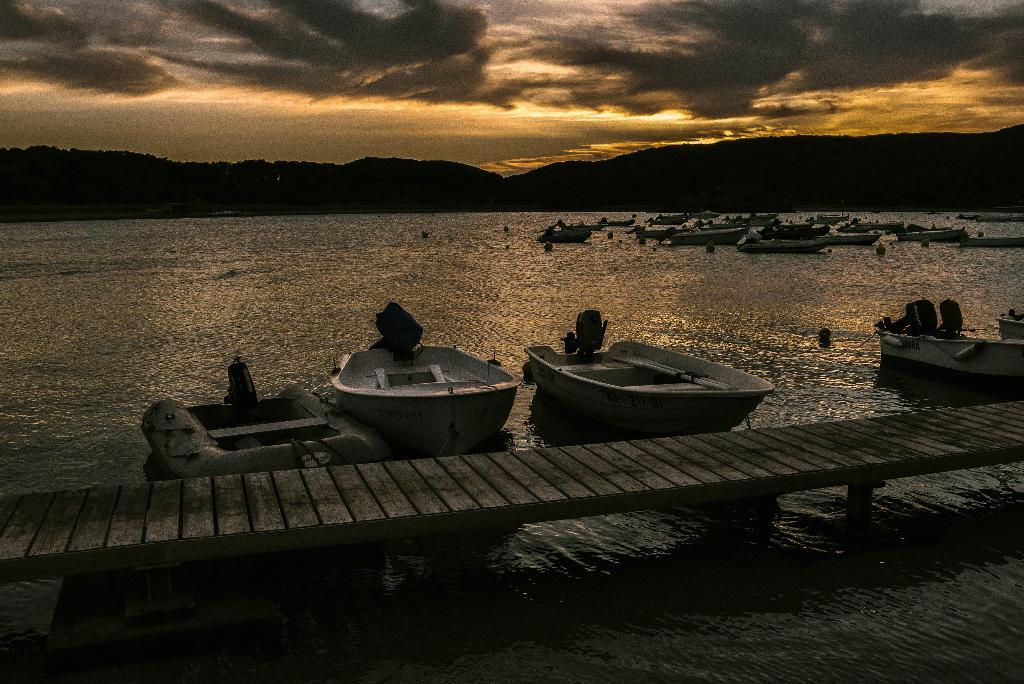What type of vehicles can be seen in the image? There are boats in the image. What structure is present in the image? There is a wooden bridge in the image. What natural element is visible in the image? There is water visible in the image. What is visible at the top of the image? The sky is visible at the top of the image. Reasoning: Let's let's think step by step in order to produce the conversation. We start by identifying the main subjects and objects in the image based on the provided facts. We then formulate questions that focus on the location and characteristics of these subjects and objects, ensuring that each question can be answered definitively with the information given. We avoid yes/no questions and ensure that the language is simple and clear. Absurd Question/Answer: What type of farm animals can be seen grazing on the hour in the image? There is no farm or hour present in the image; it features boats, a wooden bridge, water, and the sky. What type of army vehicles are visible in the image? There are no army vehicles present in the image; it features boats, a wooden bridge, water, and the sky. What type of farm animals can be seen grazing on the hour in the image? There is no farm or hour present in the image; it features boats, a wooden bridge, water, and the sky. What type of army vehicles are visible in the image? There are no army vehicles present in the image; it features boats, a wooden bridge, water, and the sky. 